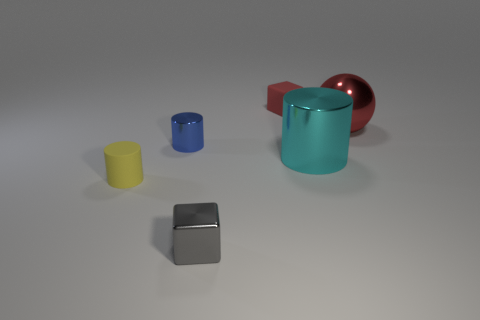Subtract all purple blocks. Subtract all blue cylinders. How many blocks are left? 2 Subtract all purple cubes. How many green balls are left? 0 Add 3 tiny yellows. How many blues exist? 0 Subtract all gray matte spheres. Subtract all blue shiny things. How many objects are left? 5 Add 6 red rubber objects. How many red rubber objects are left? 7 Add 3 yellow matte objects. How many yellow matte objects exist? 4 Add 4 small cyan metallic objects. How many objects exist? 10 Subtract all gray blocks. How many blocks are left? 1 Subtract all small rubber cylinders. How many cylinders are left? 2 Subtract 0 green blocks. How many objects are left? 6 